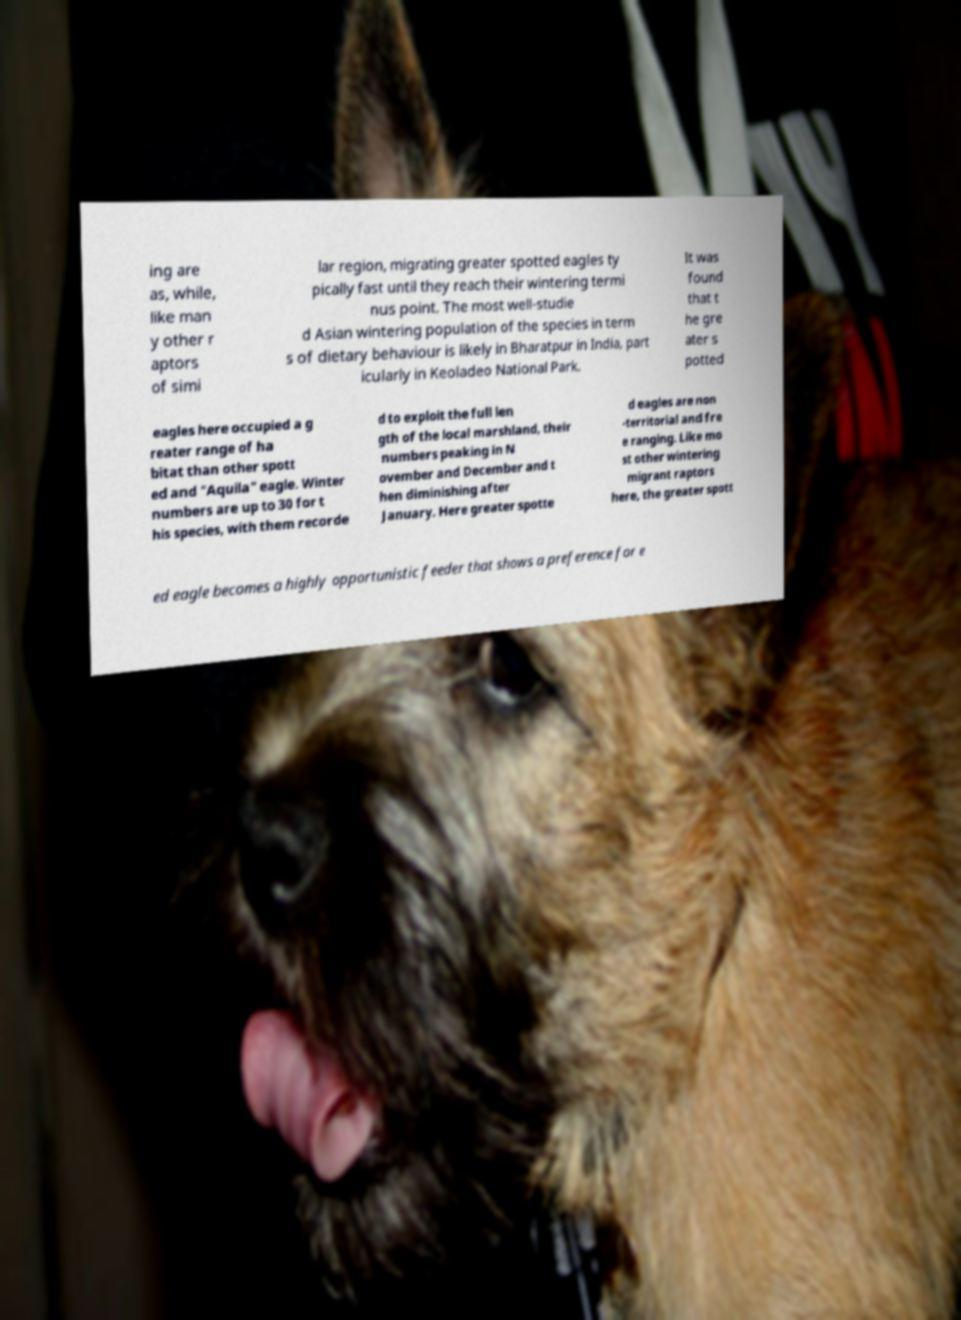What messages or text are displayed in this image? I need them in a readable, typed format. ing are as, while, like man y other r aptors of simi lar region, migrating greater spotted eagles ty pically fast until they reach their wintering termi nus point. The most well-studie d Asian wintering population of the species in term s of dietary behaviour is likely in Bharatpur in India, part icularly in Keoladeo National Park. It was found that t he gre ater s potted eagles here occupied a g reater range of ha bitat than other spott ed and "Aquila" eagle. Winter numbers are up to 30 for t his species, with them recorde d to exploit the full len gth of the local marshland, their numbers peaking in N ovember and December and t hen diminishing after January. Here greater spotte d eagles are non -territorial and fre e ranging. Like mo st other wintering migrant raptors here, the greater spott ed eagle becomes a highly opportunistic feeder that shows a preference for e 